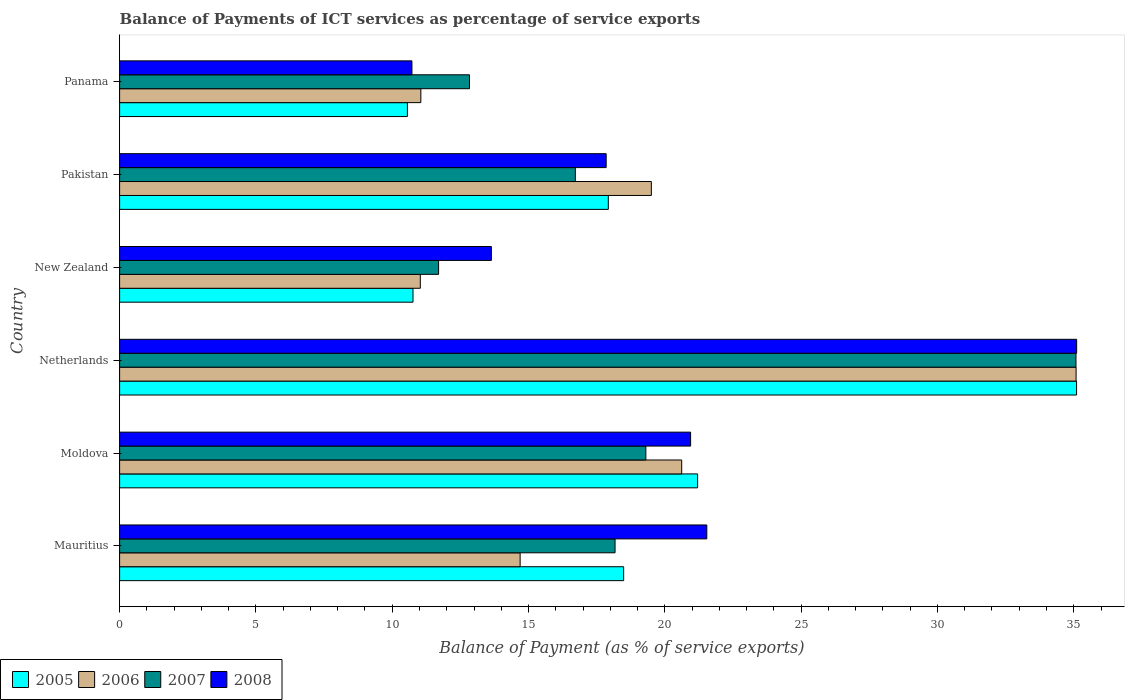Are the number of bars per tick equal to the number of legend labels?
Your answer should be compact. Yes. Are the number of bars on each tick of the Y-axis equal?
Make the answer very short. Yes. How many bars are there on the 1st tick from the top?
Your answer should be compact. 4. What is the label of the 1st group of bars from the top?
Offer a very short reply. Panama. In how many cases, is the number of bars for a given country not equal to the number of legend labels?
Keep it short and to the point. 0. What is the balance of payments of ICT services in 2008 in Panama?
Ensure brevity in your answer.  10.72. Across all countries, what is the maximum balance of payments of ICT services in 2005?
Offer a terse response. 35.1. Across all countries, what is the minimum balance of payments of ICT services in 2007?
Ensure brevity in your answer.  11.7. In which country was the balance of payments of ICT services in 2006 minimum?
Provide a short and direct response. New Zealand. What is the total balance of payments of ICT services in 2008 in the graph?
Keep it short and to the point. 119.8. What is the difference between the balance of payments of ICT services in 2007 in Netherlands and that in New Zealand?
Provide a succinct answer. 23.38. What is the difference between the balance of payments of ICT services in 2006 in Moldova and the balance of payments of ICT services in 2005 in New Zealand?
Offer a terse response. 9.86. What is the average balance of payments of ICT services in 2008 per country?
Make the answer very short. 19.97. What is the difference between the balance of payments of ICT services in 2005 and balance of payments of ICT services in 2006 in Pakistan?
Your answer should be compact. -1.58. In how many countries, is the balance of payments of ICT services in 2005 greater than 8 %?
Ensure brevity in your answer.  6. What is the ratio of the balance of payments of ICT services in 2008 in Netherlands to that in New Zealand?
Offer a terse response. 2.57. Is the balance of payments of ICT services in 2007 in Moldova less than that in Pakistan?
Keep it short and to the point. No. What is the difference between the highest and the second highest balance of payments of ICT services in 2007?
Give a very brief answer. 15.78. What is the difference between the highest and the lowest balance of payments of ICT services in 2007?
Your answer should be very brief. 23.38. Are the values on the major ticks of X-axis written in scientific E-notation?
Provide a succinct answer. No. Does the graph contain any zero values?
Keep it short and to the point. No. What is the title of the graph?
Provide a short and direct response. Balance of Payments of ICT services as percentage of service exports. Does "2013" appear as one of the legend labels in the graph?
Provide a short and direct response. No. What is the label or title of the X-axis?
Your response must be concise. Balance of Payment (as % of service exports). What is the Balance of Payment (as % of service exports) of 2005 in Mauritius?
Offer a terse response. 18.49. What is the Balance of Payment (as % of service exports) in 2006 in Mauritius?
Your answer should be very brief. 14.69. What is the Balance of Payment (as % of service exports) of 2007 in Mauritius?
Keep it short and to the point. 18.17. What is the Balance of Payment (as % of service exports) of 2008 in Mauritius?
Give a very brief answer. 21.54. What is the Balance of Payment (as % of service exports) of 2005 in Moldova?
Provide a short and direct response. 21.2. What is the Balance of Payment (as % of service exports) in 2006 in Moldova?
Your response must be concise. 20.62. What is the Balance of Payment (as % of service exports) of 2007 in Moldova?
Offer a terse response. 19.3. What is the Balance of Payment (as % of service exports) of 2008 in Moldova?
Offer a terse response. 20.95. What is the Balance of Payment (as % of service exports) in 2005 in Netherlands?
Make the answer very short. 35.1. What is the Balance of Payment (as % of service exports) in 2006 in Netherlands?
Offer a terse response. 35.09. What is the Balance of Payment (as % of service exports) of 2007 in Netherlands?
Ensure brevity in your answer.  35.08. What is the Balance of Payment (as % of service exports) of 2008 in Netherlands?
Make the answer very short. 35.11. What is the Balance of Payment (as % of service exports) in 2005 in New Zealand?
Provide a succinct answer. 10.76. What is the Balance of Payment (as % of service exports) in 2006 in New Zealand?
Your answer should be compact. 11.03. What is the Balance of Payment (as % of service exports) of 2007 in New Zealand?
Your answer should be compact. 11.7. What is the Balance of Payment (as % of service exports) of 2008 in New Zealand?
Offer a terse response. 13.64. What is the Balance of Payment (as % of service exports) in 2005 in Pakistan?
Your answer should be compact. 17.93. What is the Balance of Payment (as % of service exports) of 2006 in Pakistan?
Provide a succinct answer. 19.51. What is the Balance of Payment (as % of service exports) of 2007 in Pakistan?
Give a very brief answer. 16.72. What is the Balance of Payment (as % of service exports) in 2008 in Pakistan?
Keep it short and to the point. 17.85. What is the Balance of Payment (as % of service exports) of 2005 in Panama?
Your response must be concise. 10.56. What is the Balance of Payment (as % of service exports) of 2006 in Panama?
Make the answer very short. 11.05. What is the Balance of Payment (as % of service exports) of 2007 in Panama?
Your answer should be compact. 12.83. What is the Balance of Payment (as % of service exports) of 2008 in Panama?
Give a very brief answer. 10.72. Across all countries, what is the maximum Balance of Payment (as % of service exports) in 2005?
Provide a succinct answer. 35.1. Across all countries, what is the maximum Balance of Payment (as % of service exports) in 2006?
Provide a short and direct response. 35.09. Across all countries, what is the maximum Balance of Payment (as % of service exports) in 2007?
Your answer should be very brief. 35.08. Across all countries, what is the maximum Balance of Payment (as % of service exports) of 2008?
Your answer should be very brief. 35.11. Across all countries, what is the minimum Balance of Payment (as % of service exports) in 2005?
Your response must be concise. 10.56. Across all countries, what is the minimum Balance of Payment (as % of service exports) in 2006?
Provide a short and direct response. 11.03. Across all countries, what is the minimum Balance of Payment (as % of service exports) of 2007?
Provide a short and direct response. 11.7. Across all countries, what is the minimum Balance of Payment (as % of service exports) in 2008?
Make the answer very short. 10.72. What is the total Balance of Payment (as % of service exports) in 2005 in the graph?
Your answer should be very brief. 114.04. What is the total Balance of Payment (as % of service exports) of 2006 in the graph?
Provide a short and direct response. 111.98. What is the total Balance of Payment (as % of service exports) in 2007 in the graph?
Offer a very short reply. 113.81. What is the total Balance of Payment (as % of service exports) in 2008 in the graph?
Make the answer very short. 119.8. What is the difference between the Balance of Payment (as % of service exports) of 2005 in Mauritius and that in Moldova?
Your answer should be compact. -2.71. What is the difference between the Balance of Payment (as % of service exports) in 2006 in Mauritius and that in Moldova?
Ensure brevity in your answer.  -5.93. What is the difference between the Balance of Payment (as % of service exports) of 2007 in Mauritius and that in Moldova?
Offer a terse response. -1.13. What is the difference between the Balance of Payment (as % of service exports) of 2008 in Mauritius and that in Moldova?
Keep it short and to the point. 0.59. What is the difference between the Balance of Payment (as % of service exports) of 2005 in Mauritius and that in Netherlands?
Your answer should be compact. -16.61. What is the difference between the Balance of Payment (as % of service exports) of 2006 in Mauritius and that in Netherlands?
Keep it short and to the point. -20.39. What is the difference between the Balance of Payment (as % of service exports) of 2007 in Mauritius and that in Netherlands?
Your answer should be very brief. -16.91. What is the difference between the Balance of Payment (as % of service exports) in 2008 in Mauritius and that in Netherlands?
Provide a succinct answer. -13.57. What is the difference between the Balance of Payment (as % of service exports) in 2005 in Mauritius and that in New Zealand?
Keep it short and to the point. 7.73. What is the difference between the Balance of Payment (as % of service exports) of 2006 in Mauritius and that in New Zealand?
Your response must be concise. 3.66. What is the difference between the Balance of Payment (as % of service exports) of 2007 in Mauritius and that in New Zealand?
Your response must be concise. 6.47. What is the difference between the Balance of Payment (as % of service exports) of 2008 in Mauritius and that in New Zealand?
Make the answer very short. 7.9. What is the difference between the Balance of Payment (as % of service exports) in 2005 in Mauritius and that in Pakistan?
Offer a terse response. 0.56. What is the difference between the Balance of Payment (as % of service exports) of 2006 in Mauritius and that in Pakistan?
Give a very brief answer. -4.81. What is the difference between the Balance of Payment (as % of service exports) of 2007 in Mauritius and that in Pakistan?
Your answer should be very brief. 1.46. What is the difference between the Balance of Payment (as % of service exports) in 2008 in Mauritius and that in Pakistan?
Provide a short and direct response. 3.69. What is the difference between the Balance of Payment (as % of service exports) in 2005 in Mauritius and that in Panama?
Provide a succinct answer. 7.93. What is the difference between the Balance of Payment (as % of service exports) of 2006 in Mauritius and that in Panama?
Offer a terse response. 3.64. What is the difference between the Balance of Payment (as % of service exports) in 2007 in Mauritius and that in Panama?
Ensure brevity in your answer.  5.34. What is the difference between the Balance of Payment (as % of service exports) in 2008 in Mauritius and that in Panama?
Make the answer very short. 10.82. What is the difference between the Balance of Payment (as % of service exports) in 2005 in Moldova and that in Netherlands?
Keep it short and to the point. -13.9. What is the difference between the Balance of Payment (as % of service exports) of 2006 in Moldova and that in Netherlands?
Your answer should be very brief. -14.47. What is the difference between the Balance of Payment (as % of service exports) in 2007 in Moldova and that in Netherlands?
Your answer should be compact. -15.78. What is the difference between the Balance of Payment (as % of service exports) of 2008 in Moldova and that in Netherlands?
Keep it short and to the point. -14.16. What is the difference between the Balance of Payment (as % of service exports) of 2005 in Moldova and that in New Zealand?
Keep it short and to the point. 10.44. What is the difference between the Balance of Payment (as % of service exports) of 2006 in Moldova and that in New Zealand?
Keep it short and to the point. 9.59. What is the difference between the Balance of Payment (as % of service exports) of 2007 in Moldova and that in New Zealand?
Offer a terse response. 7.6. What is the difference between the Balance of Payment (as % of service exports) in 2008 in Moldova and that in New Zealand?
Your answer should be compact. 7.31. What is the difference between the Balance of Payment (as % of service exports) in 2005 in Moldova and that in Pakistan?
Ensure brevity in your answer.  3.28. What is the difference between the Balance of Payment (as % of service exports) in 2006 in Moldova and that in Pakistan?
Your answer should be very brief. 1.11. What is the difference between the Balance of Payment (as % of service exports) of 2007 in Moldova and that in Pakistan?
Offer a terse response. 2.59. What is the difference between the Balance of Payment (as % of service exports) of 2008 in Moldova and that in Pakistan?
Make the answer very short. 3.1. What is the difference between the Balance of Payment (as % of service exports) of 2005 in Moldova and that in Panama?
Your answer should be very brief. 10.65. What is the difference between the Balance of Payment (as % of service exports) in 2006 in Moldova and that in Panama?
Your response must be concise. 9.57. What is the difference between the Balance of Payment (as % of service exports) of 2007 in Moldova and that in Panama?
Your answer should be compact. 6.47. What is the difference between the Balance of Payment (as % of service exports) in 2008 in Moldova and that in Panama?
Give a very brief answer. 10.22. What is the difference between the Balance of Payment (as % of service exports) of 2005 in Netherlands and that in New Zealand?
Keep it short and to the point. 24.34. What is the difference between the Balance of Payment (as % of service exports) of 2006 in Netherlands and that in New Zealand?
Keep it short and to the point. 24.05. What is the difference between the Balance of Payment (as % of service exports) in 2007 in Netherlands and that in New Zealand?
Make the answer very short. 23.38. What is the difference between the Balance of Payment (as % of service exports) of 2008 in Netherlands and that in New Zealand?
Provide a short and direct response. 21.47. What is the difference between the Balance of Payment (as % of service exports) in 2005 in Netherlands and that in Pakistan?
Make the answer very short. 17.18. What is the difference between the Balance of Payment (as % of service exports) in 2006 in Netherlands and that in Pakistan?
Keep it short and to the point. 15.58. What is the difference between the Balance of Payment (as % of service exports) in 2007 in Netherlands and that in Pakistan?
Keep it short and to the point. 18.36. What is the difference between the Balance of Payment (as % of service exports) in 2008 in Netherlands and that in Pakistan?
Your response must be concise. 17.26. What is the difference between the Balance of Payment (as % of service exports) of 2005 in Netherlands and that in Panama?
Keep it short and to the point. 24.55. What is the difference between the Balance of Payment (as % of service exports) in 2006 in Netherlands and that in Panama?
Provide a succinct answer. 24.04. What is the difference between the Balance of Payment (as % of service exports) in 2007 in Netherlands and that in Panama?
Provide a succinct answer. 22.25. What is the difference between the Balance of Payment (as % of service exports) in 2008 in Netherlands and that in Panama?
Offer a very short reply. 24.38. What is the difference between the Balance of Payment (as % of service exports) of 2005 in New Zealand and that in Pakistan?
Make the answer very short. -7.16. What is the difference between the Balance of Payment (as % of service exports) of 2006 in New Zealand and that in Pakistan?
Ensure brevity in your answer.  -8.47. What is the difference between the Balance of Payment (as % of service exports) in 2007 in New Zealand and that in Pakistan?
Your answer should be very brief. -5.02. What is the difference between the Balance of Payment (as % of service exports) in 2008 in New Zealand and that in Pakistan?
Provide a succinct answer. -4.21. What is the difference between the Balance of Payment (as % of service exports) in 2005 in New Zealand and that in Panama?
Keep it short and to the point. 0.2. What is the difference between the Balance of Payment (as % of service exports) in 2006 in New Zealand and that in Panama?
Give a very brief answer. -0.02. What is the difference between the Balance of Payment (as % of service exports) of 2007 in New Zealand and that in Panama?
Keep it short and to the point. -1.13. What is the difference between the Balance of Payment (as % of service exports) of 2008 in New Zealand and that in Panama?
Keep it short and to the point. 2.91. What is the difference between the Balance of Payment (as % of service exports) in 2005 in Pakistan and that in Panama?
Keep it short and to the point. 7.37. What is the difference between the Balance of Payment (as % of service exports) in 2006 in Pakistan and that in Panama?
Ensure brevity in your answer.  8.46. What is the difference between the Balance of Payment (as % of service exports) of 2007 in Pakistan and that in Panama?
Your answer should be very brief. 3.88. What is the difference between the Balance of Payment (as % of service exports) of 2008 in Pakistan and that in Panama?
Ensure brevity in your answer.  7.12. What is the difference between the Balance of Payment (as % of service exports) of 2005 in Mauritius and the Balance of Payment (as % of service exports) of 2006 in Moldova?
Your answer should be compact. -2.13. What is the difference between the Balance of Payment (as % of service exports) in 2005 in Mauritius and the Balance of Payment (as % of service exports) in 2007 in Moldova?
Your response must be concise. -0.81. What is the difference between the Balance of Payment (as % of service exports) in 2005 in Mauritius and the Balance of Payment (as % of service exports) in 2008 in Moldova?
Your answer should be compact. -2.46. What is the difference between the Balance of Payment (as % of service exports) in 2006 in Mauritius and the Balance of Payment (as % of service exports) in 2007 in Moldova?
Provide a succinct answer. -4.61. What is the difference between the Balance of Payment (as % of service exports) of 2006 in Mauritius and the Balance of Payment (as % of service exports) of 2008 in Moldova?
Make the answer very short. -6.25. What is the difference between the Balance of Payment (as % of service exports) of 2007 in Mauritius and the Balance of Payment (as % of service exports) of 2008 in Moldova?
Your answer should be compact. -2.77. What is the difference between the Balance of Payment (as % of service exports) in 2005 in Mauritius and the Balance of Payment (as % of service exports) in 2006 in Netherlands?
Ensure brevity in your answer.  -16.6. What is the difference between the Balance of Payment (as % of service exports) of 2005 in Mauritius and the Balance of Payment (as % of service exports) of 2007 in Netherlands?
Your response must be concise. -16.59. What is the difference between the Balance of Payment (as % of service exports) in 2005 in Mauritius and the Balance of Payment (as % of service exports) in 2008 in Netherlands?
Ensure brevity in your answer.  -16.62. What is the difference between the Balance of Payment (as % of service exports) of 2006 in Mauritius and the Balance of Payment (as % of service exports) of 2007 in Netherlands?
Ensure brevity in your answer.  -20.39. What is the difference between the Balance of Payment (as % of service exports) of 2006 in Mauritius and the Balance of Payment (as % of service exports) of 2008 in Netherlands?
Make the answer very short. -20.41. What is the difference between the Balance of Payment (as % of service exports) of 2007 in Mauritius and the Balance of Payment (as % of service exports) of 2008 in Netherlands?
Your response must be concise. -16.93. What is the difference between the Balance of Payment (as % of service exports) of 2005 in Mauritius and the Balance of Payment (as % of service exports) of 2006 in New Zealand?
Provide a succinct answer. 7.46. What is the difference between the Balance of Payment (as % of service exports) of 2005 in Mauritius and the Balance of Payment (as % of service exports) of 2007 in New Zealand?
Offer a very short reply. 6.79. What is the difference between the Balance of Payment (as % of service exports) of 2005 in Mauritius and the Balance of Payment (as % of service exports) of 2008 in New Zealand?
Your answer should be compact. 4.85. What is the difference between the Balance of Payment (as % of service exports) in 2006 in Mauritius and the Balance of Payment (as % of service exports) in 2007 in New Zealand?
Offer a very short reply. 2.99. What is the difference between the Balance of Payment (as % of service exports) in 2006 in Mauritius and the Balance of Payment (as % of service exports) in 2008 in New Zealand?
Your response must be concise. 1.05. What is the difference between the Balance of Payment (as % of service exports) of 2007 in Mauritius and the Balance of Payment (as % of service exports) of 2008 in New Zealand?
Your response must be concise. 4.54. What is the difference between the Balance of Payment (as % of service exports) in 2005 in Mauritius and the Balance of Payment (as % of service exports) in 2006 in Pakistan?
Make the answer very short. -1.02. What is the difference between the Balance of Payment (as % of service exports) in 2005 in Mauritius and the Balance of Payment (as % of service exports) in 2007 in Pakistan?
Keep it short and to the point. 1.77. What is the difference between the Balance of Payment (as % of service exports) in 2005 in Mauritius and the Balance of Payment (as % of service exports) in 2008 in Pakistan?
Your response must be concise. 0.64. What is the difference between the Balance of Payment (as % of service exports) in 2006 in Mauritius and the Balance of Payment (as % of service exports) in 2007 in Pakistan?
Make the answer very short. -2.03. What is the difference between the Balance of Payment (as % of service exports) of 2006 in Mauritius and the Balance of Payment (as % of service exports) of 2008 in Pakistan?
Your answer should be very brief. -3.16. What is the difference between the Balance of Payment (as % of service exports) in 2007 in Mauritius and the Balance of Payment (as % of service exports) in 2008 in Pakistan?
Ensure brevity in your answer.  0.33. What is the difference between the Balance of Payment (as % of service exports) of 2005 in Mauritius and the Balance of Payment (as % of service exports) of 2006 in Panama?
Provide a succinct answer. 7.44. What is the difference between the Balance of Payment (as % of service exports) of 2005 in Mauritius and the Balance of Payment (as % of service exports) of 2007 in Panama?
Your response must be concise. 5.66. What is the difference between the Balance of Payment (as % of service exports) of 2005 in Mauritius and the Balance of Payment (as % of service exports) of 2008 in Panama?
Keep it short and to the point. 7.77. What is the difference between the Balance of Payment (as % of service exports) of 2006 in Mauritius and the Balance of Payment (as % of service exports) of 2007 in Panama?
Offer a very short reply. 1.86. What is the difference between the Balance of Payment (as % of service exports) in 2006 in Mauritius and the Balance of Payment (as % of service exports) in 2008 in Panama?
Make the answer very short. 3.97. What is the difference between the Balance of Payment (as % of service exports) in 2007 in Mauritius and the Balance of Payment (as % of service exports) in 2008 in Panama?
Ensure brevity in your answer.  7.45. What is the difference between the Balance of Payment (as % of service exports) in 2005 in Moldova and the Balance of Payment (as % of service exports) in 2006 in Netherlands?
Offer a terse response. -13.88. What is the difference between the Balance of Payment (as % of service exports) of 2005 in Moldova and the Balance of Payment (as % of service exports) of 2007 in Netherlands?
Ensure brevity in your answer.  -13.88. What is the difference between the Balance of Payment (as % of service exports) of 2005 in Moldova and the Balance of Payment (as % of service exports) of 2008 in Netherlands?
Your response must be concise. -13.9. What is the difference between the Balance of Payment (as % of service exports) in 2006 in Moldova and the Balance of Payment (as % of service exports) in 2007 in Netherlands?
Offer a very short reply. -14.46. What is the difference between the Balance of Payment (as % of service exports) of 2006 in Moldova and the Balance of Payment (as % of service exports) of 2008 in Netherlands?
Make the answer very short. -14.49. What is the difference between the Balance of Payment (as % of service exports) of 2007 in Moldova and the Balance of Payment (as % of service exports) of 2008 in Netherlands?
Provide a succinct answer. -15.8. What is the difference between the Balance of Payment (as % of service exports) in 2005 in Moldova and the Balance of Payment (as % of service exports) in 2006 in New Zealand?
Offer a very short reply. 10.17. What is the difference between the Balance of Payment (as % of service exports) in 2005 in Moldova and the Balance of Payment (as % of service exports) in 2007 in New Zealand?
Give a very brief answer. 9.5. What is the difference between the Balance of Payment (as % of service exports) in 2005 in Moldova and the Balance of Payment (as % of service exports) in 2008 in New Zealand?
Your response must be concise. 7.57. What is the difference between the Balance of Payment (as % of service exports) of 2006 in Moldova and the Balance of Payment (as % of service exports) of 2007 in New Zealand?
Your response must be concise. 8.92. What is the difference between the Balance of Payment (as % of service exports) in 2006 in Moldova and the Balance of Payment (as % of service exports) in 2008 in New Zealand?
Your response must be concise. 6.98. What is the difference between the Balance of Payment (as % of service exports) of 2007 in Moldova and the Balance of Payment (as % of service exports) of 2008 in New Zealand?
Your response must be concise. 5.67. What is the difference between the Balance of Payment (as % of service exports) in 2005 in Moldova and the Balance of Payment (as % of service exports) in 2006 in Pakistan?
Offer a very short reply. 1.7. What is the difference between the Balance of Payment (as % of service exports) of 2005 in Moldova and the Balance of Payment (as % of service exports) of 2007 in Pakistan?
Keep it short and to the point. 4.49. What is the difference between the Balance of Payment (as % of service exports) of 2005 in Moldova and the Balance of Payment (as % of service exports) of 2008 in Pakistan?
Offer a very short reply. 3.35. What is the difference between the Balance of Payment (as % of service exports) of 2006 in Moldova and the Balance of Payment (as % of service exports) of 2007 in Pakistan?
Make the answer very short. 3.9. What is the difference between the Balance of Payment (as % of service exports) of 2006 in Moldova and the Balance of Payment (as % of service exports) of 2008 in Pakistan?
Give a very brief answer. 2.77. What is the difference between the Balance of Payment (as % of service exports) in 2007 in Moldova and the Balance of Payment (as % of service exports) in 2008 in Pakistan?
Make the answer very short. 1.46. What is the difference between the Balance of Payment (as % of service exports) of 2005 in Moldova and the Balance of Payment (as % of service exports) of 2006 in Panama?
Provide a succinct answer. 10.15. What is the difference between the Balance of Payment (as % of service exports) of 2005 in Moldova and the Balance of Payment (as % of service exports) of 2007 in Panama?
Keep it short and to the point. 8.37. What is the difference between the Balance of Payment (as % of service exports) in 2005 in Moldova and the Balance of Payment (as % of service exports) in 2008 in Panama?
Your answer should be very brief. 10.48. What is the difference between the Balance of Payment (as % of service exports) of 2006 in Moldova and the Balance of Payment (as % of service exports) of 2007 in Panama?
Provide a succinct answer. 7.78. What is the difference between the Balance of Payment (as % of service exports) in 2006 in Moldova and the Balance of Payment (as % of service exports) in 2008 in Panama?
Offer a very short reply. 9.9. What is the difference between the Balance of Payment (as % of service exports) of 2007 in Moldova and the Balance of Payment (as % of service exports) of 2008 in Panama?
Make the answer very short. 8.58. What is the difference between the Balance of Payment (as % of service exports) of 2005 in Netherlands and the Balance of Payment (as % of service exports) of 2006 in New Zealand?
Your answer should be very brief. 24.07. What is the difference between the Balance of Payment (as % of service exports) of 2005 in Netherlands and the Balance of Payment (as % of service exports) of 2007 in New Zealand?
Provide a short and direct response. 23.4. What is the difference between the Balance of Payment (as % of service exports) in 2005 in Netherlands and the Balance of Payment (as % of service exports) in 2008 in New Zealand?
Ensure brevity in your answer.  21.47. What is the difference between the Balance of Payment (as % of service exports) of 2006 in Netherlands and the Balance of Payment (as % of service exports) of 2007 in New Zealand?
Your answer should be compact. 23.38. What is the difference between the Balance of Payment (as % of service exports) of 2006 in Netherlands and the Balance of Payment (as % of service exports) of 2008 in New Zealand?
Offer a terse response. 21.45. What is the difference between the Balance of Payment (as % of service exports) in 2007 in Netherlands and the Balance of Payment (as % of service exports) in 2008 in New Zealand?
Provide a short and direct response. 21.44. What is the difference between the Balance of Payment (as % of service exports) in 2005 in Netherlands and the Balance of Payment (as % of service exports) in 2006 in Pakistan?
Your answer should be very brief. 15.6. What is the difference between the Balance of Payment (as % of service exports) in 2005 in Netherlands and the Balance of Payment (as % of service exports) in 2007 in Pakistan?
Keep it short and to the point. 18.39. What is the difference between the Balance of Payment (as % of service exports) of 2005 in Netherlands and the Balance of Payment (as % of service exports) of 2008 in Pakistan?
Provide a short and direct response. 17.25. What is the difference between the Balance of Payment (as % of service exports) in 2006 in Netherlands and the Balance of Payment (as % of service exports) in 2007 in Pakistan?
Keep it short and to the point. 18.37. What is the difference between the Balance of Payment (as % of service exports) in 2006 in Netherlands and the Balance of Payment (as % of service exports) in 2008 in Pakistan?
Make the answer very short. 17.24. What is the difference between the Balance of Payment (as % of service exports) of 2007 in Netherlands and the Balance of Payment (as % of service exports) of 2008 in Pakistan?
Your response must be concise. 17.23. What is the difference between the Balance of Payment (as % of service exports) in 2005 in Netherlands and the Balance of Payment (as % of service exports) in 2006 in Panama?
Offer a very short reply. 24.05. What is the difference between the Balance of Payment (as % of service exports) of 2005 in Netherlands and the Balance of Payment (as % of service exports) of 2007 in Panama?
Provide a short and direct response. 22.27. What is the difference between the Balance of Payment (as % of service exports) in 2005 in Netherlands and the Balance of Payment (as % of service exports) in 2008 in Panama?
Give a very brief answer. 24.38. What is the difference between the Balance of Payment (as % of service exports) in 2006 in Netherlands and the Balance of Payment (as % of service exports) in 2007 in Panama?
Ensure brevity in your answer.  22.25. What is the difference between the Balance of Payment (as % of service exports) of 2006 in Netherlands and the Balance of Payment (as % of service exports) of 2008 in Panama?
Your response must be concise. 24.36. What is the difference between the Balance of Payment (as % of service exports) of 2007 in Netherlands and the Balance of Payment (as % of service exports) of 2008 in Panama?
Provide a short and direct response. 24.36. What is the difference between the Balance of Payment (as % of service exports) in 2005 in New Zealand and the Balance of Payment (as % of service exports) in 2006 in Pakistan?
Your response must be concise. -8.74. What is the difference between the Balance of Payment (as % of service exports) in 2005 in New Zealand and the Balance of Payment (as % of service exports) in 2007 in Pakistan?
Give a very brief answer. -5.96. What is the difference between the Balance of Payment (as % of service exports) in 2005 in New Zealand and the Balance of Payment (as % of service exports) in 2008 in Pakistan?
Keep it short and to the point. -7.09. What is the difference between the Balance of Payment (as % of service exports) in 2006 in New Zealand and the Balance of Payment (as % of service exports) in 2007 in Pakistan?
Your answer should be very brief. -5.69. What is the difference between the Balance of Payment (as % of service exports) of 2006 in New Zealand and the Balance of Payment (as % of service exports) of 2008 in Pakistan?
Offer a terse response. -6.82. What is the difference between the Balance of Payment (as % of service exports) in 2007 in New Zealand and the Balance of Payment (as % of service exports) in 2008 in Pakistan?
Your response must be concise. -6.15. What is the difference between the Balance of Payment (as % of service exports) of 2005 in New Zealand and the Balance of Payment (as % of service exports) of 2006 in Panama?
Provide a succinct answer. -0.29. What is the difference between the Balance of Payment (as % of service exports) of 2005 in New Zealand and the Balance of Payment (as % of service exports) of 2007 in Panama?
Keep it short and to the point. -2.07. What is the difference between the Balance of Payment (as % of service exports) of 2005 in New Zealand and the Balance of Payment (as % of service exports) of 2008 in Panama?
Your answer should be very brief. 0.04. What is the difference between the Balance of Payment (as % of service exports) in 2006 in New Zealand and the Balance of Payment (as % of service exports) in 2007 in Panama?
Your answer should be compact. -1.8. What is the difference between the Balance of Payment (as % of service exports) in 2006 in New Zealand and the Balance of Payment (as % of service exports) in 2008 in Panama?
Give a very brief answer. 0.31. What is the difference between the Balance of Payment (as % of service exports) of 2007 in New Zealand and the Balance of Payment (as % of service exports) of 2008 in Panama?
Your answer should be compact. 0.98. What is the difference between the Balance of Payment (as % of service exports) of 2005 in Pakistan and the Balance of Payment (as % of service exports) of 2006 in Panama?
Provide a short and direct response. 6.88. What is the difference between the Balance of Payment (as % of service exports) of 2005 in Pakistan and the Balance of Payment (as % of service exports) of 2007 in Panama?
Keep it short and to the point. 5.09. What is the difference between the Balance of Payment (as % of service exports) of 2005 in Pakistan and the Balance of Payment (as % of service exports) of 2008 in Panama?
Provide a short and direct response. 7.2. What is the difference between the Balance of Payment (as % of service exports) in 2006 in Pakistan and the Balance of Payment (as % of service exports) in 2007 in Panama?
Your answer should be very brief. 6.67. What is the difference between the Balance of Payment (as % of service exports) of 2006 in Pakistan and the Balance of Payment (as % of service exports) of 2008 in Panama?
Keep it short and to the point. 8.78. What is the difference between the Balance of Payment (as % of service exports) of 2007 in Pakistan and the Balance of Payment (as % of service exports) of 2008 in Panama?
Keep it short and to the point. 5.99. What is the average Balance of Payment (as % of service exports) of 2005 per country?
Give a very brief answer. 19.01. What is the average Balance of Payment (as % of service exports) of 2006 per country?
Offer a terse response. 18.66. What is the average Balance of Payment (as % of service exports) in 2007 per country?
Keep it short and to the point. 18.97. What is the average Balance of Payment (as % of service exports) of 2008 per country?
Give a very brief answer. 19.97. What is the difference between the Balance of Payment (as % of service exports) of 2005 and Balance of Payment (as % of service exports) of 2006 in Mauritius?
Your answer should be compact. 3.8. What is the difference between the Balance of Payment (as % of service exports) of 2005 and Balance of Payment (as % of service exports) of 2007 in Mauritius?
Your answer should be compact. 0.32. What is the difference between the Balance of Payment (as % of service exports) in 2005 and Balance of Payment (as % of service exports) in 2008 in Mauritius?
Your answer should be compact. -3.05. What is the difference between the Balance of Payment (as % of service exports) in 2006 and Balance of Payment (as % of service exports) in 2007 in Mauritius?
Give a very brief answer. -3.48. What is the difference between the Balance of Payment (as % of service exports) in 2006 and Balance of Payment (as % of service exports) in 2008 in Mauritius?
Make the answer very short. -6.85. What is the difference between the Balance of Payment (as % of service exports) of 2007 and Balance of Payment (as % of service exports) of 2008 in Mauritius?
Your response must be concise. -3.37. What is the difference between the Balance of Payment (as % of service exports) of 2005 and Balance of Payment (as % of service exports) of 2006 in Moldova?
Your answer should be very brief. 0.58. What is the difference between the Balance of Payment (as % of service exports) of 2005 and Balance of Payment (as % of service exports) of 2007 in Moldova?
Your response must be concise. 1.9. What is the difference between the Balance of Payment (as % of service exports) of 2005 and Balance of Payment (as % of service exports) of 2008 in Moldova?
Make the answer very short. 0.26. What is the difference between the Balance of Payment (as % of service exports) in 2006 and Balance of Payment (as % of service exports) in 2007 in Moldova?
Provide a succinct answer. 1.31. What is the difference between the Balance of Payment (as % of service exports) of 2006 and Balance of Payment (as % of service exports) of 2008 in Moldova?
Offer a terse response. -0.33. What is the difference between the Balance of Payment (as % of service exports) in 2007 and Balance of Payment (as % of service exports) in 2008 in Moldova?
Your answer should be very brief. -1.64. What is the difference between the Balance of Payment (as % of service exports) of 2005 and Balance of Payment (as % of service exports) of 2006 in Netherlands?
Keep it short and to the point. 0.02. What is the difference between the Balance of Payment (as % of service exports) of 2005 and Balance of Payment (as % of service exports) of 2007 in Netherlands?
Offer a very short reply. 0.02. What is the difference between the Balance of Payment (as % of service exports) of 2005 and Balance of Payment (as % of service exports) of 2008 in Netherlands?
Keep it short and to the point. -0. What is the difference between the Balance of Payment (as % of service exports) of 2006 and Balance of Payment (as % of service exports) of 2007 in Netherlands?
Ensure brevity in your answer.  0. What is the difference between the Balance of Payment (as % of service exports) of 2006 and Balance of Payment (as % of service exports) of 2008 in Netherlands?
Your answer should be very brief. -0.02. What is the difference between the Balance of Payment (as % of service exports) in 2007 and Balance of Payment (as % of service exports) in 2008 in Netherlands?
Give a very brief answer. -0.02. What is the difference between the Balance of Payment (as % of service exports) in 2005 and Balance of Payment (as % of service exports) in 2006 in New Zealand?
Provide a short and direct response. -0.27. What is the difference between the Balance of Payment (as % of service exports) in 2005 and Balance of Payment (as % of service exports) in 2007 in New Zealand?
Provide a short and direct response. -0.94. What is the difference between the Balance of Payment (as % of service exports) of 2005 and Balance of Payment (as % of service exports) of 2008 in New Zealand?
Provide a short and direct response. -2.87. What is the difference between the Balance of Payment (as % of service exports) in 2006 and Balance of Payment (as % of service exports) in 2007 in New Zealand?
Provide a succinct answer. -0.67. What is the difference between the Balance of Payment (as % of service exports) of 2006 and Balance of Payment (as % of service exports) of 2008 in New Zealand?
Provide a short and direct response. -2.61. What is the difference between the Balance of Payment (as % of service exports) of 2007 and Balance of Payment (as % of service exports) of 2008 in New Zealand?
Ensure brevity in your answer.  -1.94. What is the difference between the Balance of Payment (as % of service exports) in 2005 and Balance of Payment (as % of service exports) in 2006 in Pakistan?
Your answer should be very brief. -1.58. What is the difference between the Balance of Payment (as % of service exports) of 2005 and Balance of Payment (as % of service exports) of 2007 in Pakistan?
Offer a very short reply. 1.21. What is the difference between the Balance of Payment (as % of service exports) in 2005 and Balance of Payment (as % of service exports) in 2008 in Pakistan?
Your answer should be very brief. 0.08. What is the difference between the Balance of Payment (as % of service exports) in 2006 and Balance of Payment (as % of service exports) in 2007 in Pakistan?
Keep it short and to the point. 2.79. What is the difference between the Balance of Payment (as % of service exports) in 2006 and Balance of Payment (as % of service exports) in 2008 in Pakistan?
Ensure brevity in your answer.  1.66. What is the difference between the Balance of Payment (as % of service exports) of 2007 and Balance of Payment (as % of service exports) of 2008 in Pakistan?
Make the answer very short. -1.13. What is the difference between the Balance of Payment (as % of service exports) of 2005 and Balance of Payment (as % of service exports) of 2006 in Panama?
Keep it short and to the point. -0.49. What is the difference between the Balance of Payment (as % of service exports) in 2005 and Balance of Payment (as % of service exports) in 2007 in Panama?
Your answer should be very brief. -2.28. What is the difference between the Balance of Payment (as % of service exports) in 2005 and Balance of Payment (as % of service exports) in 2008 in Panama?
Keep it short and to the point. -0.17. What is the difference between the Balance of Payment (as % of service exports) in 2006 and Balance of Payment (as % of service exports) in 2007 in Panama?
Your answer should be compact. -1.78. What is the difference between the Balance of Payment (as % of service exports) in 2006 and Balance of Payment (as % of service exports) in 2008 in Panama?
Your answer should be very brief. 0.33. What is the difference between the Balance of Payment (as % of service exports) in 2007 and Balance of Payment (as % of service exports) in 2008 in Panama?
Your answer should be compact. 2.11. What is the ratio of the Balance of Payment (as % of service exports) of 2005 in Mauritius to that in Moldova?
Offer a very short reply. 0.87. What is the ratio of the Balance of Payment (as % of service exports) in 2006 in Mauritius to that in Moldova?
Offer a terse response. 0.71. What is the ratio of the Balance of Payment (as % of service exports) of 2007 in Mauritius to that in Moldova?
Offer a terse response. 0.94. What is the ratio of the Balance of Payment (as % of service exports) of 2008 in Mauritius to that in Moldova?
Make the answer very short. 1.03. What is the ratio of the Balance of Payment (as % of service exports) in 2005 in Mauritius to that in Netherlands?
Ensure brevity in your answer.  0.53. What is the ratio of the Balance of Payment (as % of service exports) in 2006 in Mauritius to that in Netherlands?
Provide a succinct answer. 0.42. What is the ratio of the Balance of Payment (as % of service exports) of 2007 in Mauritius to that in Netherlands?
Your answer should be compact. 0.52. What is the ratio of the Balance of Payment (as % of service exports) of 2008 in Mauritius to that in Netherlands?
Your answer should be compact. 0.61. What is the ratio of the Balance of Payment (as % of service exports) of 2005 in Mauritius to that in New Zealand?
Give a very brief answer. 1.72. What is the ratio of the Balance of Payment (as % of service exports) in 2006 in Mauritius to that in New Zealand?
Give a very brief answer. 1.33. What is the ratio of the Balance of Payment (as % of service exports) in 2007 in Mauritius to that in New Zealand?
Keep it short and to the point. 1.55. What is the ratio of the Balance of Payment (as % of service exports) in 2008 in Mauritius to that in New Zealand?
Provide a succinct answer. 1.58. What is the ratio of the Balance of Payment (as % of service exports) of 2005 in Mauritius to that in Pakistan?
Make the answer very short. 1.03. What is the ratio of the Balance of Payment (as % of service exports) of 2006 in Mauritius to that in Pakistan?
Ensure brevity in your answer.  0.75. What is the ratio of the Balance of Payment (as % of service exports) of 2007 in Mauritius to that in Pakistan?
Provide a succinct answer. 1.09. What is the ratio of the Balance of Payment (as % of service exports) in 2008 in Mauritius to that in Pakistan?
Ensure brevity in your answer.  1.21. What is the ratio of the Balance of Payment (as % of service exports) in 2005 in Mauritius to that in Panama?
Your answer should be very brief. 1.75. What is the ratio of the Balance of Payment (as % of service exports) of 2006 in Mauritius to that in Panama?
Ensure brevity in your answer.  1.33. What is the ratio of the Balance of Payment (as % of service exports) of 2007 in Mauritius to that in Panama?
Give a very brief answer. 1.42. What is the ratio of the Balance of Payment (as % of service exports) of 2008 in Mauritius to that in Panama?
Provide a short and direct response. 2.01. What is the ratio of the Balance of Payment (as % of service exports) in 2005 in Moldova to that in Netherlands?
Your answer should be very brief. 0.6. What is the ratio of the Balance of Payment (as % of service exports) in 2006 in Moldova to that in Netherlands?
Offer a terse response. 0.59. What is the ratio of the Balance of Payment (as % of service exports) of 2007 in Moldova to that in Netherlands?
Provide a short and direct response. 0.55. What is the ratio of the Balance of Payment (as % of service exports) in 2008 in Moldova to that in Netherlands?
Your response must be concise. 0.6. What is the ratio of the Balance of Payment (as % of service exports) of 2005 in Moldova to that in New Zealand?
Provide a succinct answer. 1.97. What is the ratio of the Balance of Payment (as % of service exports) in 2006 in Moldova to that in New Zealand?
Your response must be concise. 1.87. What is the ratio of the Balance of Payment (as % of service exports) of 2007 in Moldova to that in New Zealand?
Provide a short and direct response. 1.65. What is the ratio of the Balance of Payment (as % of service exports) of 2008 in Moldova to that in New Zealand?
Offer a terse response. 1.54. What is the ratio of the Balance of Payment (as % of service exports) in 2005 in Moldova to that in Pakistan?
Provide a short and direct response. 1.18. What is the ratio of the Balance of Payment (as % of service exports) of 2006 in Moldova to that in Pakistan?
Ensure brevity in your answer.  1.06. What is the ratio of the Balance of Payment (as % of service exports) of 2007 in Moldova to that in Pakistan?
Provide a succinct answer. 1.15. What is the ratio of the Balance of Payment (as % of service exports) in 2008 in Moldova to that in Pakistan?
Provide a succinct answer. 1.17. What is the ratio of the Balance of Payment (as % of service exports) in 2005 in Moldova to that in Panama?
Provide a short and direct response. 2.01. What is the ratio of the Balance of Payment (as % of service exports) in 2006 in Moldova to that in Panama?
Offer a very short reply. 1.87. What is the ratio of the Balance of Payment (as % of service exports) in 2007 in Moldova to that in Panama?
Provide a short and direct response. 1.5. What is the ratio of the Balance of Payment (as % of service exports) of 2008 in Moldova to that in Panama?
Make the answer very short. 1.95. What is the ratio of the Balance of Payment (as % of service exports) in 2005 in Netherlands to that in New Zealand?
Your response must be concise. 3.26. What is the ratio of the Balance of Payment (as % of service exports) of 2006 in Netherlands to that in New Zealand?
Your answer should be compact. 3.18. What is the ratio of the Balance of Payment (as % of service exports) in 2007 in Netherlands to that in New Zealand?
Provide a short and direct response. 3. What is the ratio of the Balance of Payment (as % of service exports) of 2008 in Netherlands to that in New Zealand?
Your answer should be compact. 2.57. What is the ratio of the Balance of Payment (as % of service exports) of 2005 in Netherlands to that in Pakistan?
Provide a succinct answer. 1.96. What is the ratio of the Balance of Payment (as % of service exports) of 2006 in Netherlands to that in Pakistan?
Give a very brief answer. 1.8. What is the ratio of the Balance of Payment (as % of service exports) of 2007 in Netherlands to that in Pakistan?
Your response must be concise. 2.1. What is the ratio of the Balance of Payment (as % of service exports) of 2008 in Netherlands to that in Pakistan?
Ensure brevity in your answer.  1.97. What is the ratio of the Balance of Payment (as % of service exports) of 2005 in Netherlands to that in Panama?
Offer a terse response. 3.33. What is the ratio of the Balance of Payment (as % of service exports) of 2006 in Netherlands to that in Panama?
Give a very brief answer. 3.18. What is the ratio of the Balance of Payment (as % of service exports) in 2007 in Netherlands to that in Panama?
Offer a very short reply. 2.73. What is the ratio of the Balance of Payment (as % of service exports) in 2008 in Netherlands to that in Panama?
Keep it short and to the point. 3.27. What is the ratio of the Balance of Payment (as % of service exports) of 2005 in New Zealand to that in Pakistan?
Give a very brief answer. 0.6. What is the ratio of the Balance of Payment (as % of service exports) of 2006 in New Zealand to that in Pakistan?
Your answer should be very brief. 0.57. What is the ratio of the Balance of Payment (as % of service exports) in 2007 in New Zealand to that in Pakistan?
Keep it short and to the point. 0.7. What is the ratio of the Balance of Payment (as % of service exports) of 2008 in New Zealand to that in Pakistan?
Keep it short and to the point. 0.76. What is the ratio of the Balance of Payment (as % of service exports) in 2005 in New Zealand to that in Panama?
Provide a succinct answer. 1.02. What is the ratio of the Balance of Payment (as % of service exports) in 2006 in New Zealand to that in Panama?
Offer a very short reply. 1. What is the ratio of the Balance of Payment (as % of service exports) in 2007 in New Zealand to that in Panama?
Keep it short and to the point. 0.91. What is the ratio of the Balance of Payment (as % of service exports) of 2008 in New Zealand to that in Panama?
Your response must be concise. 1.27. What is the ratio of the Balance of Payment (as % of service exports) in 2005 in Pakistan to that in Panama?
Your answer should be very brief. 1.7. What is the ratio of the Balance of Payment (as % of service exports) of 2006 in Pakistan to that in Panama?
Your answer should be compact. 1.77. What is the ratio of the Balance of Payment (as % of service exports) of 2007 in Pakistan to that in Panama?
Keep it short and to the point. 1.3. What is the ratio of the Balance of Payment (as % of service exports) in 2008 in Pakistan to that in Panama?
Your response must be concise. 1.66. What is the difference between the highest and the second highest Balance of Payment (as % of service exports) in 2005?
Offer a very short reply. 13.9. What is the difference between the highest and the second highest Balance of Payment (as % of service exports) in 2006?
Your answer should be compact. 14.47. What is the difference between the highest and the second highest Balance of Payment (as % of service exports) of 2007?
Make the answer very short. 15.78. What is the difference between the highest and the second highest Balance of Payment (as % of service exports) in 2008?
Make the answer very short. 13.57. What is the difference between the highest and the lowest Balance of Payment (as % of service exports) of 2005?
Offer a terse response. 24.55. What is the difference between the highest and the lowest Balance of Payment (as % of service exports) in 2006?
Give a very brief answer. 24.05. What is the difference between the highest and the lowest Balance of Payment (as % of service exports) in 2007?
Your answer should be compact. 23.38. What is the difference between the highest and the lowest Balance of Payment (as % of service exports) in 2008?
Your response must be concise. 24.38. 